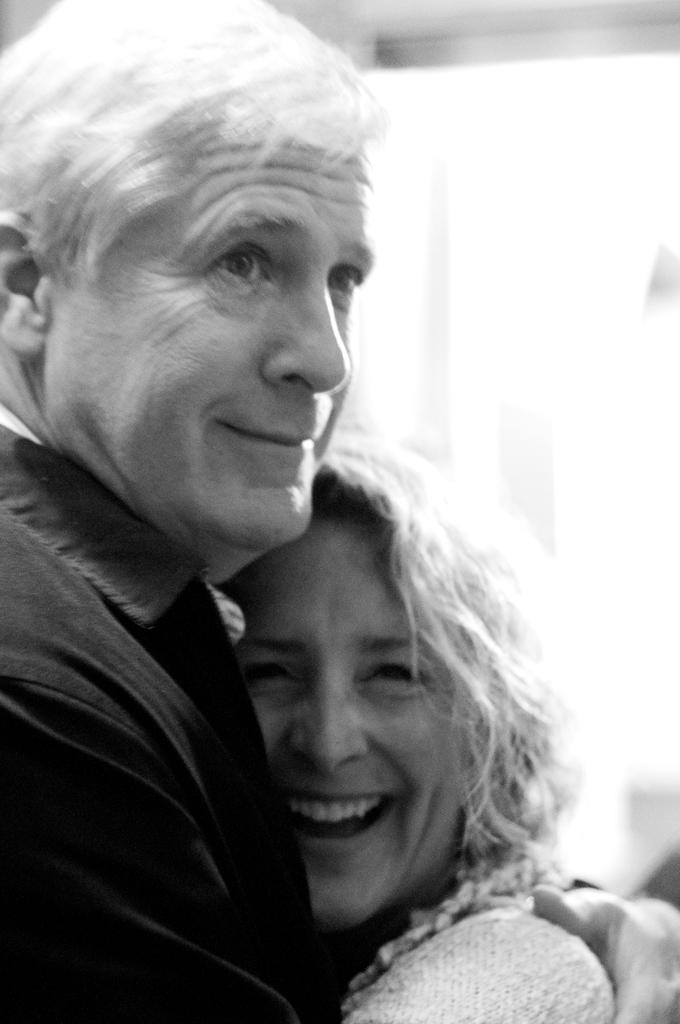Who is present in the image? There is a couple in the image. What are the couple wearing? The couple is wearing clothes. What are the couple doing in the image? The couple is hugging each other. What degree does the airport have in the image? There is no airport present in the image, so it is not possible to determine its degree. 